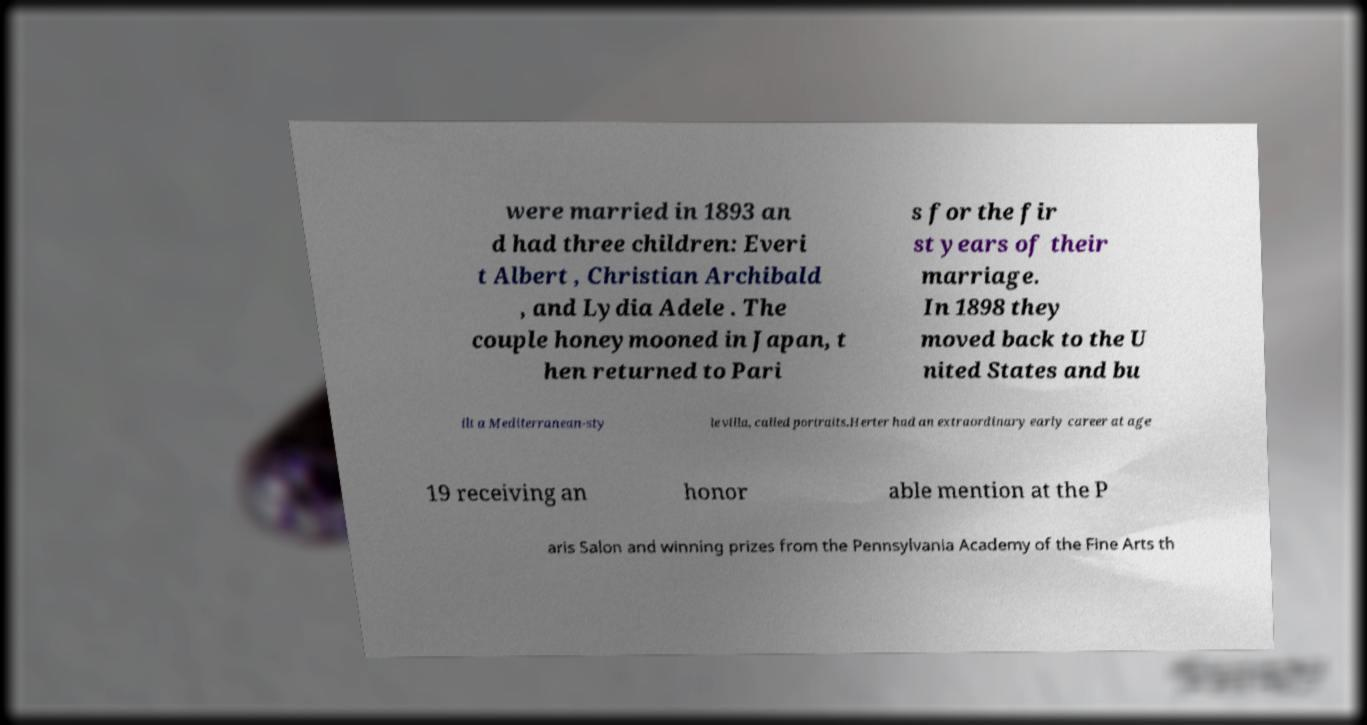For documentation purposes, I need the text within this image transcribed. Could you provide that? were married in 1893 an d had three children: Everi t Albert , Christian Archibald , and Lydia Adele . The couple honeymooned in Japan, t hen returned to Pari s for the fir st years of their marriage. In 1898 they moved back to the U nited States and bu ilt a Mediterranean-sty le villa, called portraits.Herter had an extraordinary early career at age 19 receiving an honor able mention at the P aris Salon and winning prizes from the Pennsylvania Academy of the Fine Arts th 